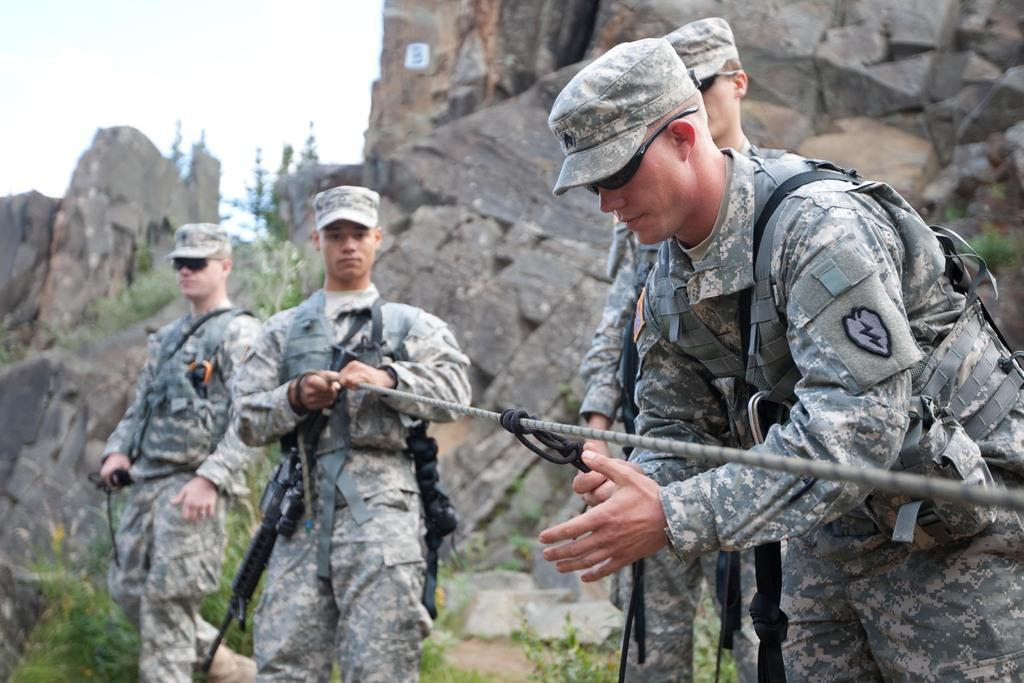What can be seen in the foreground of the picture? There are soldiers and a rope in the foreground of the picture. How would you describe the background of the image? The background of the image is blurred, and there are trees, a branch, and a hill visible. What is the condition of the sky in the image? The sky is cloudy in the image. Can you tell me how many yaks are attempting to climb the hill in the background of the image? There are no yaks present in the image, and therefore no such activity can be observed. What type of wood is used to make the soldiers' weapons in the image? There is no information about the soldiers' weapons in the image, so it cannot be determined what type of wood they might be made of. 